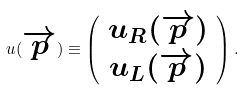Convert formula to latex. <formula><loc_0><loc_0><loc_500><loc_500>u ( \overrightarrow { p } ) \equiv \left ( \begin{array} { c } u _ { R } ( \overrightarrow { p } ) \\ u _ { L } ( \overrightarrow { p } ) \end{array} \right ) .</formula> 